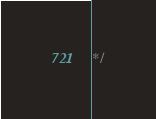Convert code to text. <code><loc_0><loc_0><loc_500><loc_500><_CSS_>*/</code> 